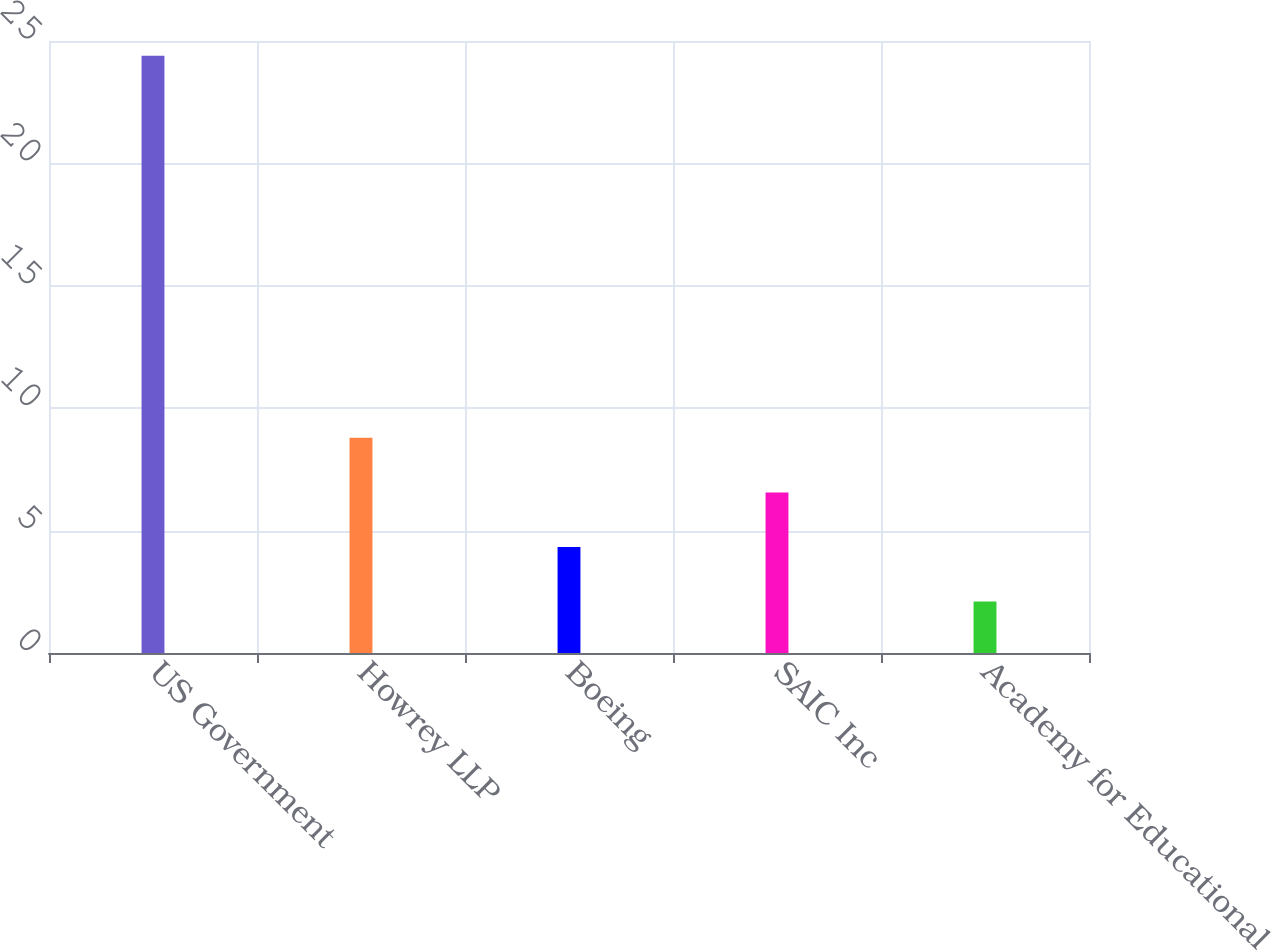Convert chart. <chart><loc_0><loc_0><loc_500><loc_500><bar_chart><fcel>US Government<fcel>Howrey LLP<fcel>Boeing<fcel>SAIC Inc<fcel>Academy for Educational<nl><fcel>24.4<fcel>8.79<fcel>4.33<fcel>6.56<fcel>2.1<nl></chart> 